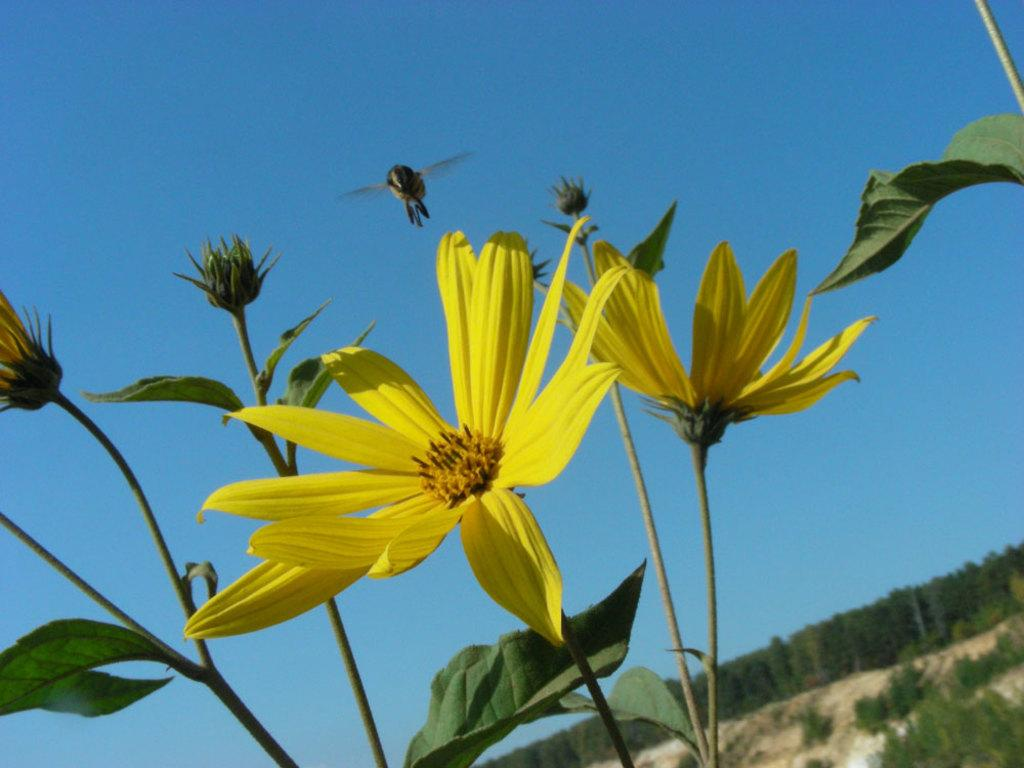What type of plants can be seen in the image? There are plants with yellow flowers in the image. What is flying in the air in the image? There is a bee flying in the air in the image. What type of vegetation is visible in the image besides the plants with yellow flowers? There are trees visible in the image. Can you feel the pain of the snow in the image? There is no snow present in the image, and therefore no pain can be felt from it. 